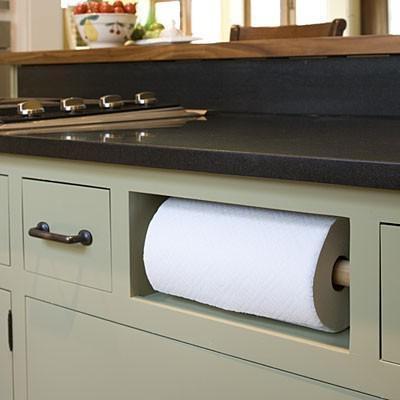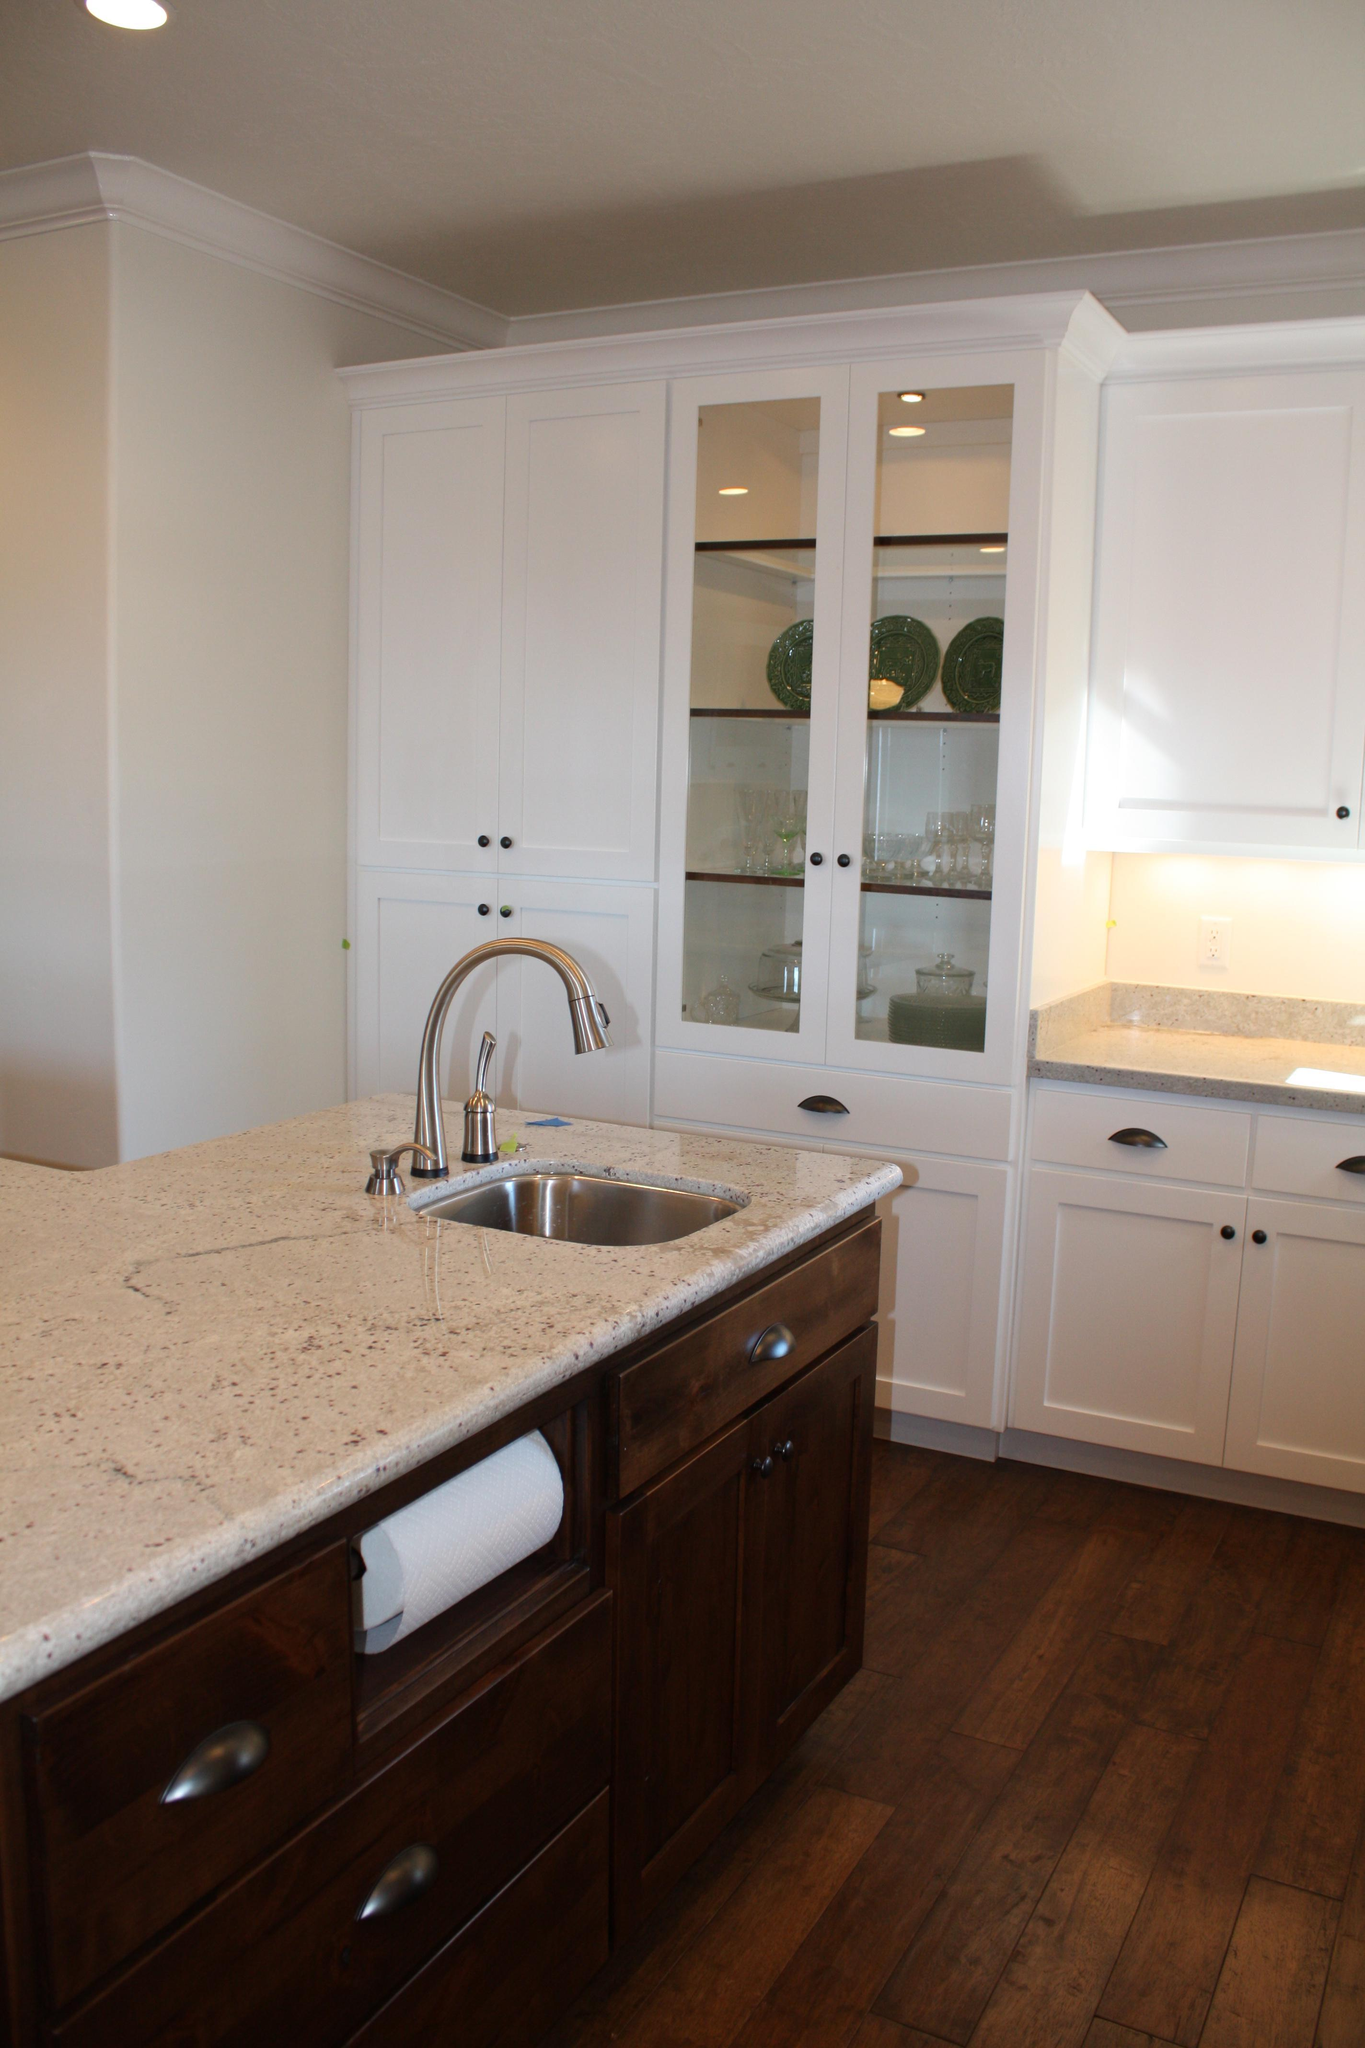The first image is the image on the left, the second image is the image on the right. Examine the images to the left and right. Is the description "The left image contains no more than one paper towel roll." accurate? Answer yes or no. Yes. The first image is the image on the left, the second image is the image on the right. Examine the images to the left and right. Is the description "One of the paper towel rolls is tucked under the upper cabinet." accurate? Answer yes or no. No. 